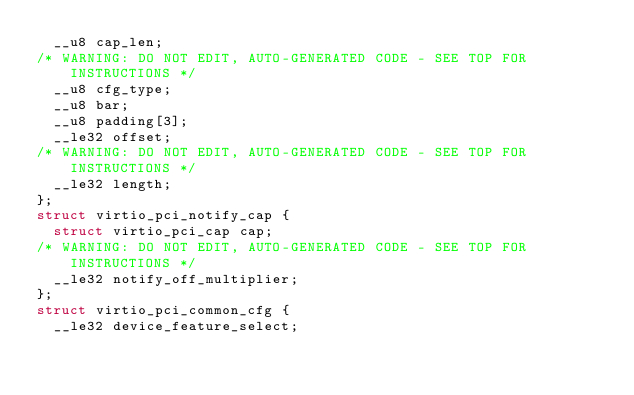<code> <loc_0><loc_0><loc_500><loc_500><_C_>  __u8 cap_len;
/* WARNING: DO NOT EDIT, AUTO-GENERATED CODE - SEE TOP FOR INSTRUCTIONS */
  __u8 cfg_type;
  __u8 bar;
  __u8 padding[3];
  __le32 offset;
/* WARNING: DO NOT EDIT, AUTO-GENERATED CODE - SEE TOP FOR INSTRUCTIONS */
  __le32 length;
};
struct virtio_pci_notify_cap {
  struct virtio_pci_cap cap;
/* WARNING: DO NOT EDIT, AUTO-GENERATED CODE - SEE TOP FOR INSTRUCTIONS */
  __le32 notify_off_multiplier;
};
struct virtio_pci_common_cfg {
  __le32 device_feature_select;</code> 